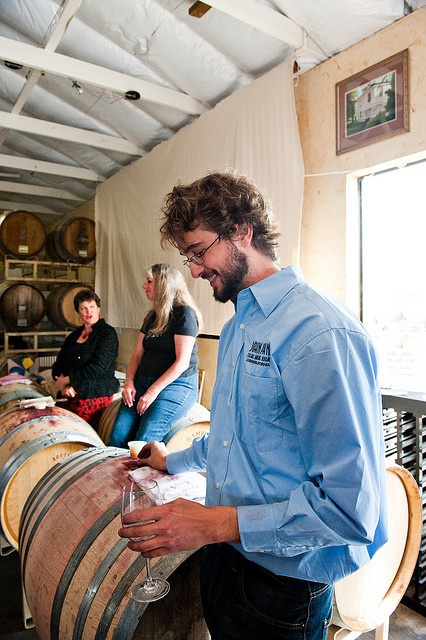Describe the objects in this image and their specific colors. I can see people in gray, black, darkgray, and teal tones, people in gray, black, white, brown, and lightblue tones, people in gray, black, maroon, and brown tones, and wine glass in gray, brown, darkgray, and lightgray tones in this image. 